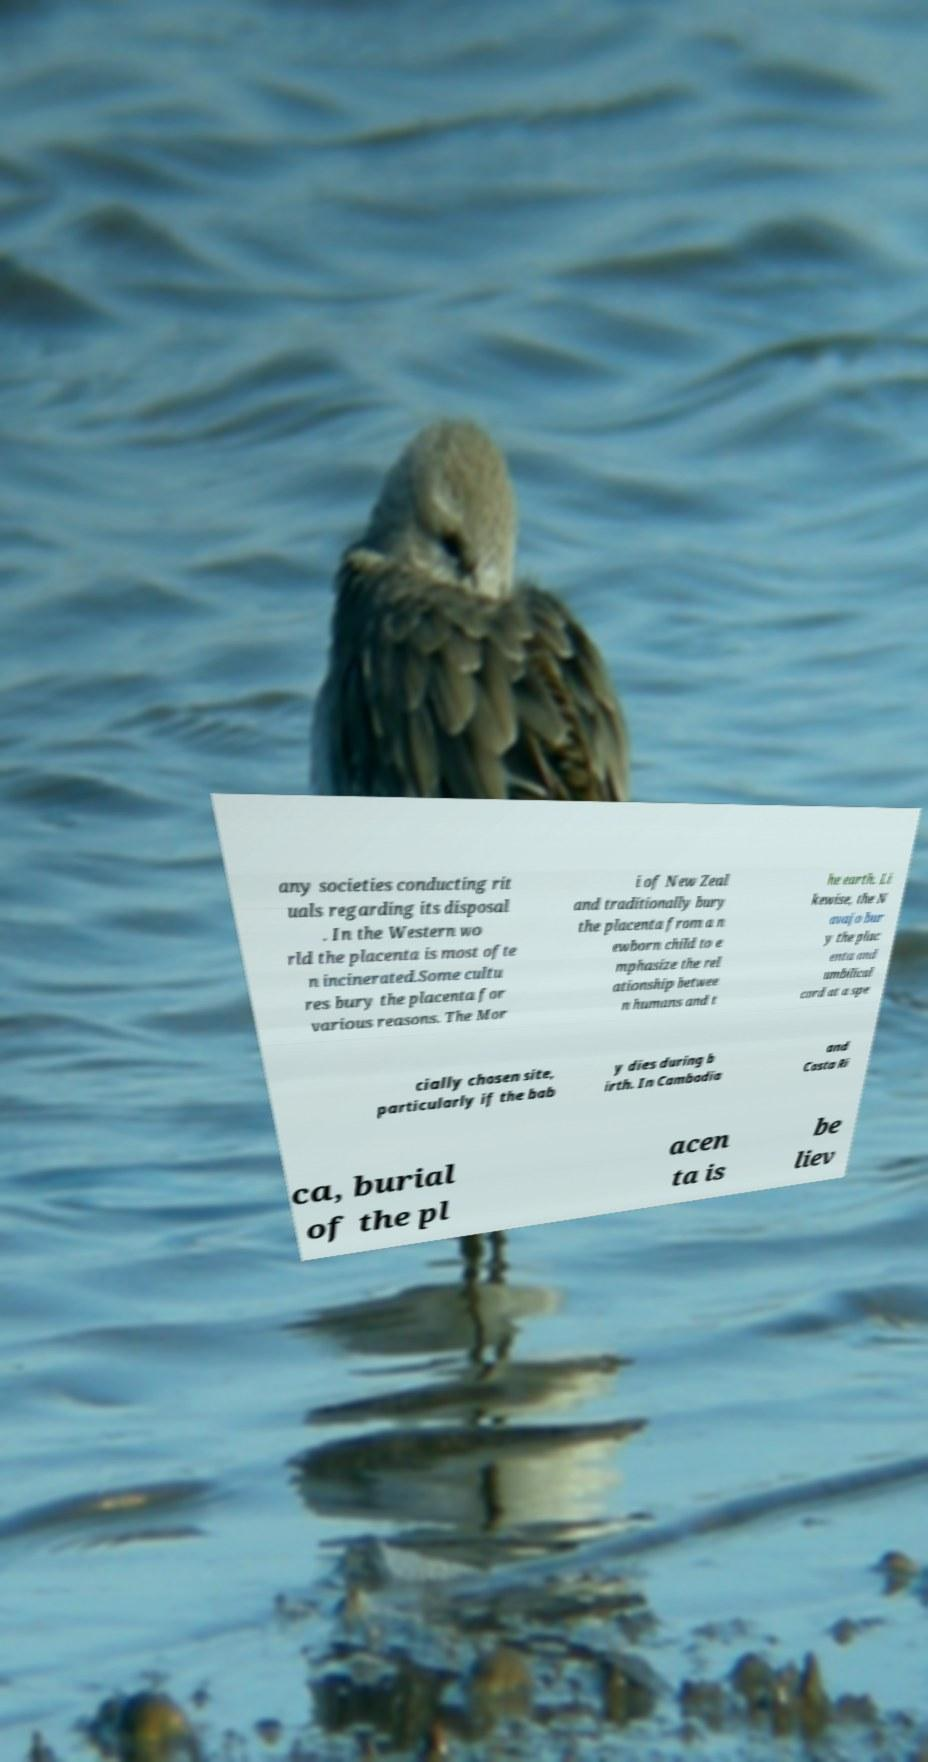Can you accurately transcribe the text from the provided image for me? any societies conducting rit uals regarding its disposal . In the Western wo rld the placenta is most ofte n incinerated.Some cultu res bury the placenta for various reasons. The Mor i of New Zeal and traditionally bury the placenta from a n ewborn child to e mphasize the rel ationship betwee n humans and t he earth. Li kewise, the N avajo bur y the plac enta and umbilical cord at a spe cially chosen site, particularly if the bab y dies during b irth. In Cambodia and Costa Ri ca, burial of the pl acen ta is be liev 